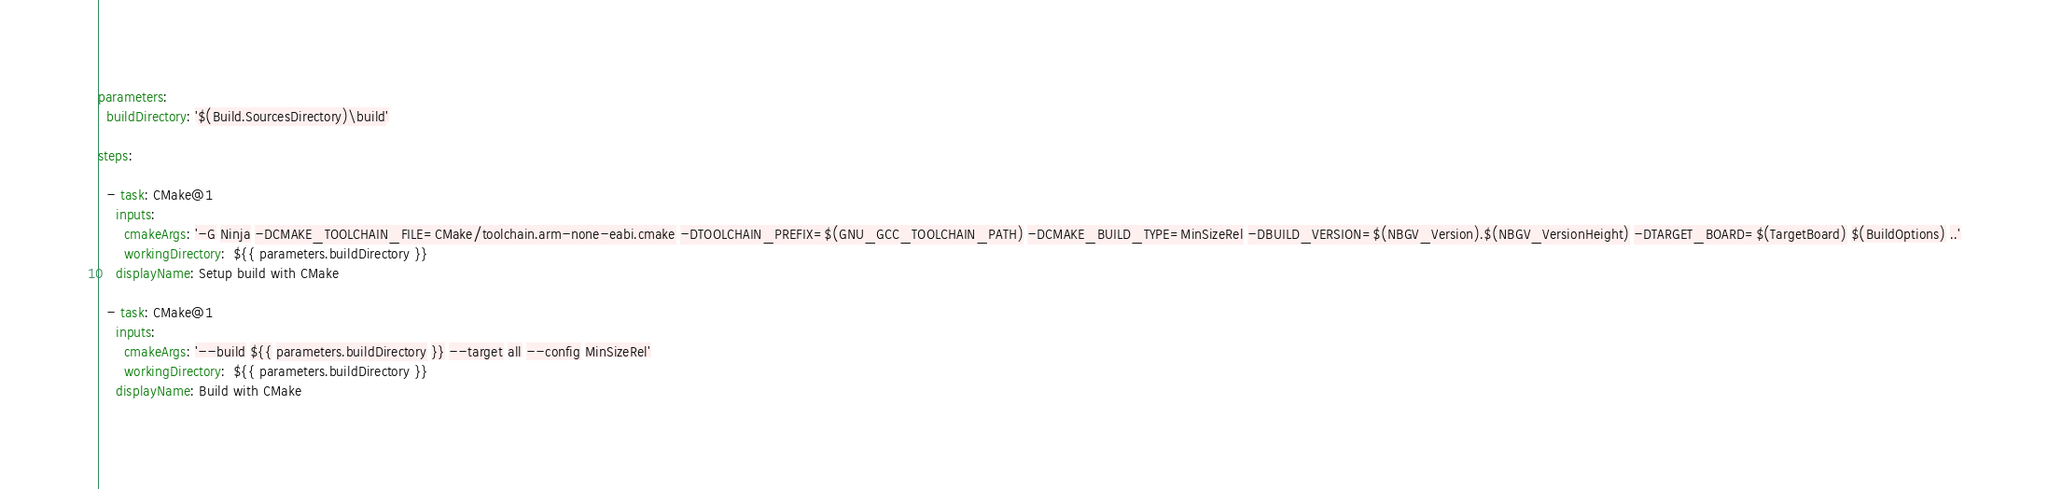Convert code to text. <code><loc_0><loc_0><loc_500><loc_500><_YAML_>
parameters:
  buildDirectory: '$(Build.SourcesDirectory)\build'

steps:

  - task: CMake@1
    inputs:
      cmakeArgs: '-G Ninja -DCMAKE_TOOLCHAIN_FILE=CMake/toolchain.arm-none-eabi.cmake -DTOOLCHAIN_PREFIX=$(GNU_GCC_TOOLCHAIN_PATH) -DCMAKE_BUILD_TYPE=MinSizeRel -DBUILD_VERSION=$(NBGV_Version).$(NBGV_VersionHeight) -DTARGET_BOARD=$(TargetBoard) $(BuildOptions) ..'
      workingDirectory:  ${{ parameters.buildDirectory }}
    displayName: Setup build with CMake

  - task: CMake@1
    inputs:
      cmakeArgs: '--build ${{ parameters.buildDirectory }} --target all --config MinSizeRel'
      workingDirectory:  ${{ parameters.buildDirectory }}
    displayName: Build with CMake
</code> 